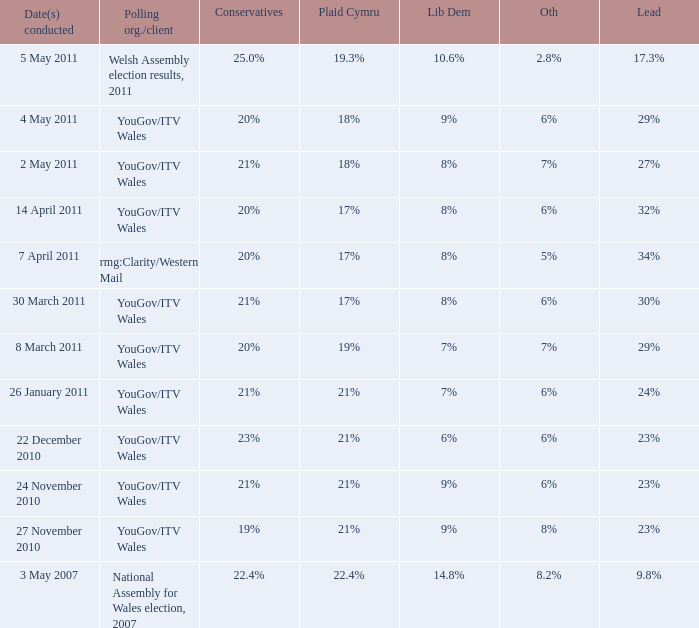What is the cons for lib dem of 8% and a lead of 27% 21%. 